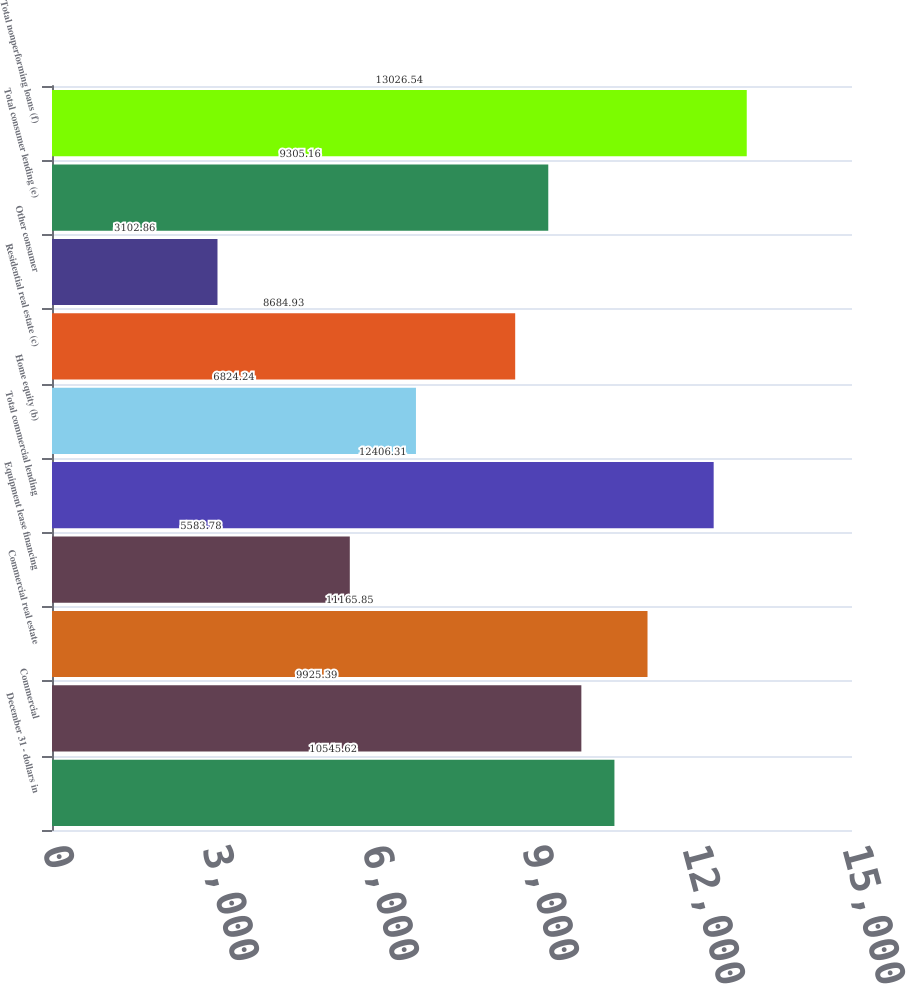Convert chart to OTSL. <chart><loc_0><loc_0><loc_500><loc_500><bar_chart><fcel>December 31 - dollars in<fcel>Commercial<fcel>Commercial real estate<fcel>Equipment lease financing<fcel>Total commercial lending<fcel>Home equity (b)<fcel>Residential real estate (c)<fcel>Other consumer<fcel>Total consumer lending (e)<fcel>Total nonperforming loans (f)<nl><fcel>10545.6<fcel>9925.39<fcel>11165.9<fcel>5583.78<fcel>12406.3<fcel>6824.24<fcel>8684.93<fcel>3102.86<fcel>9305.16<fcel>13026.5<nl></chart> 